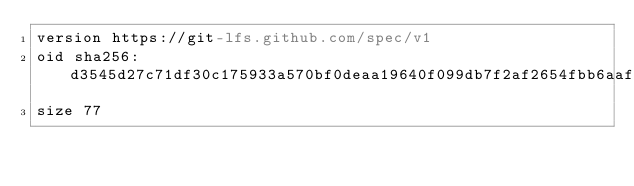Convert code to text. <code><loc_0><loc_0><loc_500><loc_500><_YAML_>version https://git-lfs.github.com/spec/v1
oid sha256:d3545d27c71df30c175933a570bf0deaa19640f099db7f2af2654fbb6aafe20e
size 77
</code> 